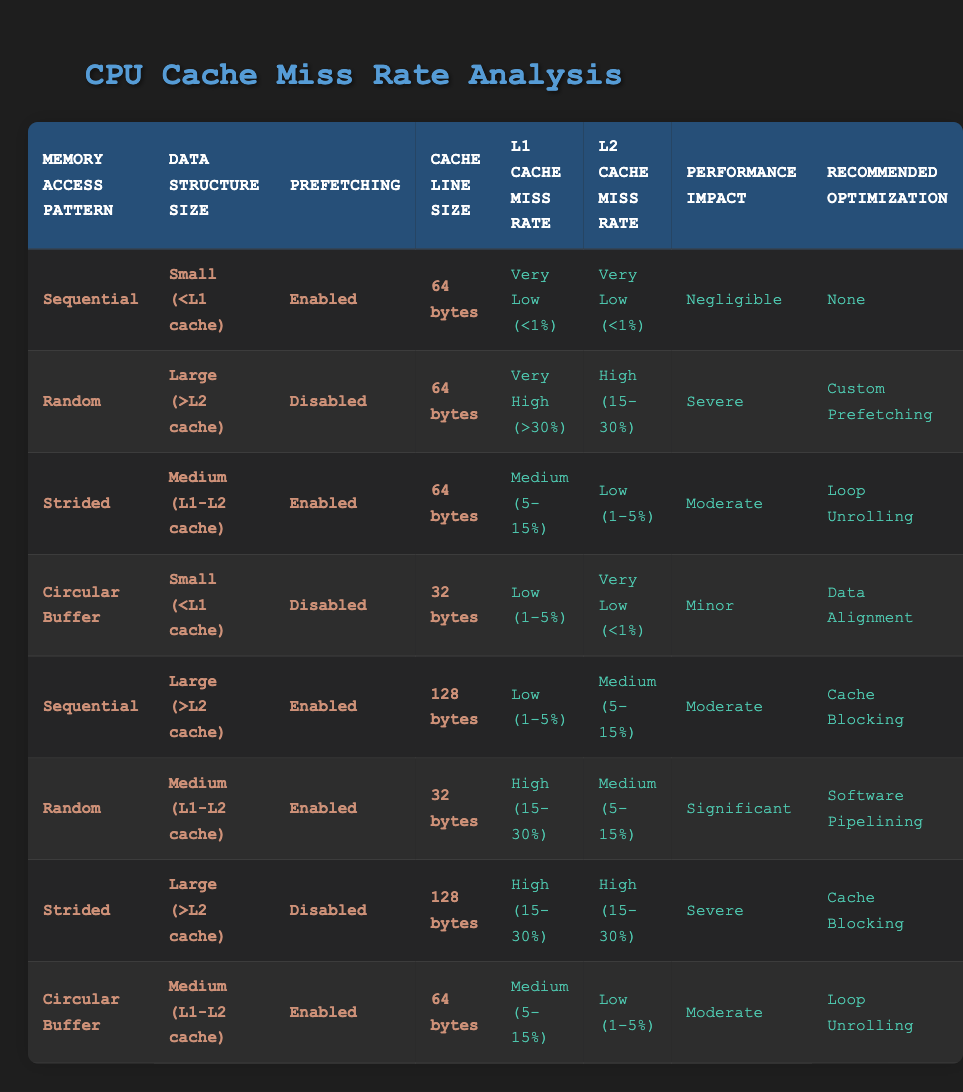What is the L1 cache miss rate for a small data structure with a sequential memory access pattern and prefetching disabled? According to the table, for a small data structure with a sequential access pattern and prefetching enabled, the L1 cache miss rate is "Very Low (<1%)". However, since the question is about prefetching disabled, we find that such a case does not exist in the provided rules. Thus, we interpret there is no applicable result for this specific condition.
Answer: No applicable result What recommended optimization corresponds to high L1 cache miss rates when memory access pattern is random and data structure size is large? For a random access pattern with a large data structure, checking the corresponding row in the table shows that the recommended optimization is "Custom Prefetching".
Answer: Custom Prefetching What is the performance impact when using a strided memory access pattern with a medium-sized data structure and prefetching enabled? In the case of a strided access pattern combined with a medium-sized data structure with prefetching enabled, we look at the relevant row, where the performance impact is indicated as "Moderate".
Answer: Moderate Are there any scenarios listed where the L2 cache miss rate is "High (15-30%)"? Reviewing the table, we see two scenarios where the L2 cache miss rate is high: the first for a strided access pattern with a large data structure and prefetching disabled, and the second for random access with a medium data structure with prefetching enabled. Therefore, yes, there are two such scenarios.
Answer: Yes What is the average L1 cache miss rate among all configurations for the "Circular Buffer" access pattern? The L1 cache miss rates for the "Circular Buffer" (low, medium) conditions can be extracted from two relevant entries: one has a rate of "Low (1-5%)" and the other has "Medium (5-15%)". To calculate the average: (3% + 10%)/2 = 6.5%.
Answer: 6.5% 